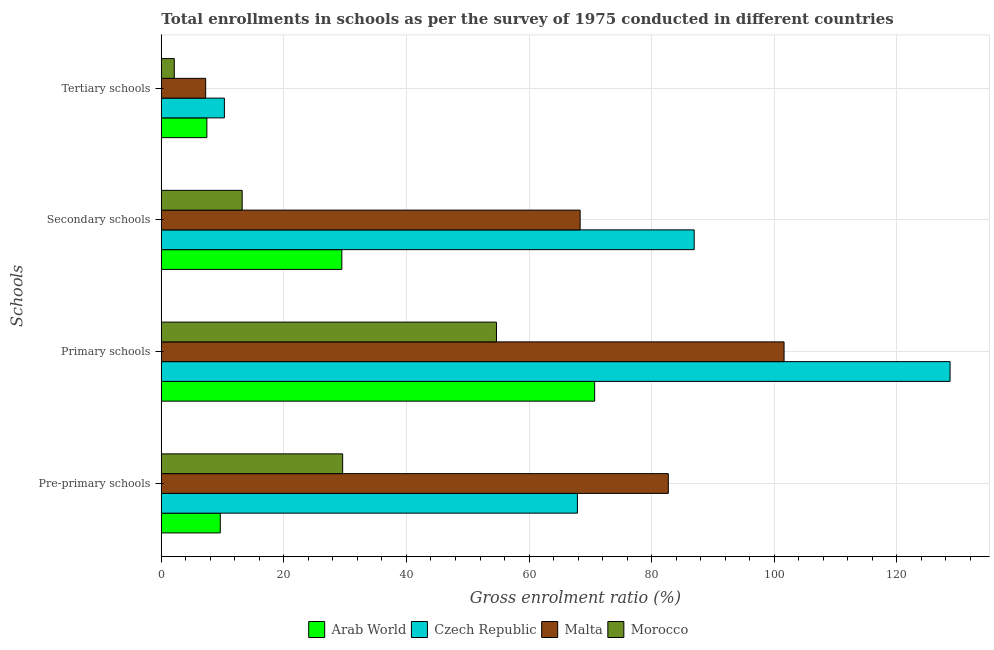How many groups of bars are there?
Offer a very short reply. 4. Are the number of bars per tick equal to the number of legend labels?
Your answer should be compact. Yes. How many bars are there on the 3rd tick from the top?
Offer a very short reply. 4. What is the label of the 2nd group of bars from the top?
Your answer should be compact. Secondary schools. What is the gross enrolment ratio in pre-primary schools in Malta?
Provide a short and direct response. 82.73. Across all countries, what is the maximum gross enrolment ratio in pre-primary schools?
Offer a terse response. 82.73. Across all countries, what is the minimum gross enrolment ratio in tertiary schools?
Provide a succinct answer. 2.12. In which country was the gross enrolment ratio in secondary schools maximum?
Your response must be concise. Czech Republic. In which country was the gross enrolment ratio in secondary schools minimum?
Provide a short and direct response. Morocco. What is the total gross enrolment ratio in secondary schools in the graph?
Offer a very short reply. 197.94. What is the difference between the gross enrolment ratio in secondary schools in Malta and that in Czech Republic?
Your answer should be very brief. -18.61. What is the difference between the gross enrolment ratio in pre-primary schools in Morocco and the gross enrolment ratio in tertiary schools in Czech Republic?
Offer a terse response. 19.3. What is the average gross enrolment ratio in pre-primary schools per country?
Offer a terse response. 47.46. What is the difference between the gross enrolment ratio in secondary schools and gross enrolment ratio in tertiary schools in Malta?
Keep it short and to the point. 61.11. What is the ratio of the gross enrolment ratio in pre-primary schools in Morocco to that in Czech Republic?
Make the answer very short. 0.44. Is the difference between the gross enrolment ratio in secondary schools in Czech Republic and Malta greater than the difference between the gross enrolment ratio in tertiary schools in Czech Republic and Malta?
Your response must be concise. Yes. What is the difference between the highest and the second highest gross enrolment ratio in tertiary schools?
Your answer should be compact. 2.86. What is the difference between the highest and the lowest gross enrolment ratio in pre-primary schools?
Give a very brief answer. 73.1. In how many countries, is the gross enrolment ratio in primary schools greater than the average gross enrolment ratio in primary schools taken over all countries?
Provide a short and direct response. 2. Is it the case that in every country, the sum of the gross enrolment ratio in secondary schools and gross enrolment ratio in pre-primary schools is greater than the sum of gross enrolment ratio in primary schools and gross enrolment ratio in tertiary schools?
Your response must be concise. Yes. What does the 2nd bar from the top in Secondary schools represents?
Offer a terse response. Malta. What does the 4th bar from the bottom in Primary schools represents?
Offer a terse response. Morocco. Is it the case that in every country, the sum of the gross enrolment ratio in pre-primary schools and gross enrolment ratio in primary schools is greater than the gross enrolment ratio in secondary schools?
Keep it short and to the point. Yes. How many bars are there?
Your answer should be compact. 16. Are all the bars in the graph horizontal?
Provide a short and direct response. Yes. How many countries are there in the graph?
Provide a short and direct response. 4. What is the difference between two consecutive major ticks on the X-axis?
Provide a succinct answer. 20. Are the values on the major ticks of X-axis written in scientific E-notation?
Give a very brief answer. No. How many legend labels are there?
Make the answer very short. 4. What is the title of the graph?
Ensure brevity in your answer.  Total enrollments in schools as per the survey of 1975 conducted in different countries. Does "Portugal" appear as one of the legend labels in the graph?
Offer a very short reply. No. What is the label or title of the X-axis?
Ensure brevity in your answer.  Gross enrolment ratio (%). What is the label or title of the Y-axis?
Give a very brief answer. Schools. What is the Gross enrolment ratio (%) in Arab World in Pre-primary schools?
Provide a short and direct response. 9.62. What is the Gross enrolment ratio (%) in Czech Republic in Pre-primary schools?
Your answer should be compact. 67.9. What is the Gross enrolment ratio (%) in Malta in Pre-primary schools?
Your answer should be compact. 82.73. What is the Gross enrolment ratio (%) of Morocco in Pre-primary schools?
Your response must be concise. 29.59. What is the Gross enrolment ratio (%) in Arab World in Primary schools?
Ensure brevity in your answer.  70.71. What is the Gross enrolment ratio (%) in Czech Republic in Primary schools?
Give a very brief answer. 128.7. What is the Gross enrolment ratio (%) in Malta in Primary schools?
Your answer should be compact. 101.62. What is the Gross enrolment ratio (%) in Morocco in Primary schools?
Your answer should be very brief. 54.69. What is the Gross enrolment ratio (%) in Arab World in Secondary schools?
Offer a very short reply. 29.46. What is the Gross enrolment ratio (%) in Czech Republic in Secondary schools?
Keep it short and to the point. 86.95. What is the Gross enrolment ratio (%) of Malta in Secondary schools?
Keep it short and to the point. 68.34. What is the Gross enrolment ratio (%) of Morocco in Secondary schools?
Your answer should be very brief. 13.19. What is the Gross enrolment ratio (%) in Arab World in Tertiary schools?
Make the answer very short. 7.44. What is the Gross enrolment ratio (%) in Czech Republic in Tertiary schools?
Give a very brief answer. 10.29. What is the Gross enrolment ratio (%) in Malta in Tertiary schools?
Provide a succinct answer. 7.24. What is the Gross enrolment ratio (%) in Morocco in Tertiary schools?
Make the answer very short. 2.12. Across all Schools, what is the maximum Gross enrolment ratio (%) of Arab World?
Keep it short and to the point. 70.71. Across all Schools, what is the maximum Gross enrolment ratio (%) in Czech Republic?
Your answer should be very brief. 128.7. Across all Schools, what is the maximum Gross enrolment ratio (%) in Malta?
Make the answer very short. 101.62. Across all Schools, what is the maximum Gross enrolment ratio (%) in Morocco?
Keep it short and to the point. 54.69. Across all Schools, what is the minimum Gross enrolment ratio (%) in Arab World?
Give a very brief answer. 7.44. Across all Schools, what is the minimum Gross enrolment ratio (%) in Czech Republic?
Provide a short and direct response. 10.29. Across all Schools, what is the minimum Gross enrolment ratio (%) in Malta?
Make the answer very short. 7.24. Across all Schools, what is the minimum Gross enrolment ratio (%) in Morocco?
Make the answer very short. 2.12. What is the total Gross enrolment ratio (%) of Arab World in the graph?
Ensure brevity in your answer.  117.22. What is the total Gross enrolment ratio (%) in Czech Republic in the graph?
Give a very brief answer. 293.84. What is the total Gross enrolment ratio (%) in Malta in the graph?
Your response must be concise. 259.92. What is the total Gross enrolment ratio (%) of Morocco in the graph?
Provide a succinct answer. 99.58. What is the difference between the Gross enrolment ratio (%) of Arab World in Pre-primary schools and that in Primary schools?
Keep it short and to the point. -61.09. What is the difference between the Gross enrolment ratio (%) in Czech Republic in Pre-primary schools and that in Primary schools?
Ensure brevity in your answer.  -60.8. What is the difference between the Gross enrolment ratio (%) in Malta in Pre-primary schools and that in Primary schools?
Your answer should be compact. -18.89. What is the difference between the Gross enrolment ratio (%) of Morocco in Pre-primary schools and that in Primary schools?
Offer a terse response. -25.1. What is the difference between the Gross enrolment ratio (%) of Arab World in Pre-primary schools and that in Secondary schools?
Provide a succinct answer. -19.83. What is the difference between the Gross enrolment ratio (%) in Czech Republic in Pre-primary schools and that in Secondary schools?
Offer a terse response. -19.05. What is the difference between the Gross enrolment ratio (%) of Malta in Pre-primary schools and that in Secondary schools?
Provide a short and direct response. 14.38. What is the difference between the Gross enrolment ratio (%) of Morocco in Pre-primary schools and that in Secondary schools?
Provide a succinct answer. 16.39. What is the difference between the Gross enrolment ratio (%) of Arab World in Pre-primary schools and that in Tertiary schools?
Your answer should be very brief. 2.19. What is the difference between the Gross enrolment ratio (%) of Czech Republic in Pre-primary schools and that in Tertiary schools?
Your answer should be very brief. 57.61. What is the difference between the Gross enrolment ratio (%) of Malta in Pre-primary schools and that in Tertiary schools?
Your answer should be compact. 75.49. What is the difference between the Gross enrolment ratio (%) of Morocco in Pre-primary schools and that in Tertiary schools?
Offer a very short reply. 27.47. What is the difference between the Gross enrolment ratio (%) in Arab World in Primary schools and that in Secondary schools?
Your response must be concise. 41.25. What is the difference between the Gross enrolment ratio (%) of Czech Republic in Primary schools and that in Secondary schools?
Provide a succinct answer. 41.75. What is the difference between the Gross enrolment ratio (%) in Malta in Primary schools and that in Secondary schools?
Offer a very short reply. 33.27. What is the difference between the Gross enrolment ratio (%) of Morocco in Primary schools and that in Secondary schools?
Give a very brief answer. 41.49. What is the difference between the Gross enrolment ratio (%) of Arab World in Primary schools and that in Tertiary schools?
Your answer should be compact. 63.27. What is the difference between the Gross enrolment ratio (%) in Czech Republic in Primary schools and that in Tertiary schools?
Your response must be concise. 118.41. What is the difference between the Gross enrolment ratio (%) of Malta in Primary schools and that in Tertiary schools?
Your response must be concise. 94.38. What is the difference between the Gross enrolment ratio (%) in Morocco in Primary schools and that in Tertiary schools?
Provide a short and direct response. 52.57. What is the difference between the Gross enrolment ratio (%) of Arab World in Secondary schools and that in Tertiary schools?
Your answer should be very brief. 22.02. What is the difference between the Gross enrolment ratio (%) in Czech Republic in Secondary schools and that in Tertiary schools?
Your answer should be very brief. 76.66. What is the difference between the Gross enrolment ratio (%) of Malta in Secondary schools and that in Tertiary schools?
Provide a succinct answer. 61.11. What is the difference between the Gross enrolment ratio (%) in Morocco in Secondary schools and that in Tertiary schools?
Your answer should be very brief. 11.08. What is the difference between the Gross enrolment ratio (%) of Arab World in Pre-primary schools and the Gross enrolment ratio (%) of Czech Republic in Primary schools?
Make the answer very short. -119.08. What is the difference between the Gross enrolment ratio (%) of Arab World in Pre-primary schools and the Gross enrolment ratio (%) of Malta in Primary schools?
Give a very brief answer. -91.99. What is the difference between the Gross enrolment ratio (%) in Arab World in Pre-primary schools and the Gross enrolment ratio (%) in Morocco in Primary schools?
Ensure brevity in your answer.  -45.07. What is the difference between the Gross enrolment ratio (%) of Czech Republic in Pre-primary schools and the Gross enrolment ratio (%) of Malta in Primary schools?
Keep it short and to the point. -33.72. What is the difference between the Gross enrolment ratio (%) of Czech Republic in Pre-primary schools and the Gross enrolment ratio (%) of Morocco in Primary schools?
Provide a succinct answer. 13.21. What is the difference between the Gross enrolment ratio (%) of Malta in Pre-primary schools and the Gross enrolment ratio (%) of Morocco in Primary schools?
Keep it short and to the point. 28.04. What is the difference between the Gross enrolment ratio (%) in Arab World in Pre-primary schools and the Gross enrolment ratio (%) in Czech Republic in Secondary schools?
Make the answer very short. -77.33. What is the difference between the Gross enrolment ratio (%) in Arab World in Pre-primary schools and the Gross enrolment ratio (%) in Malta in Secondary schools?
Give a very brief answer. -58.72. What is the difference between the Gross enrolment ratio (%) in Arab World in Pre-primary schools and the Gross enrolment ratio (%) in Morocco in Secondary schools?
Give a very brief answer. -3.57. What is the difference between the Gross enrolment ratio (%) of Czech Republic in Pre-primary schools and the Gross enrolment ratio (%) of Malta in Secondary schools?
Your answer should be very brief. -0.45. What is the difference between the Gross enrolment ratio (%) of Czech Republic in Pre-primary schools and the Gross enrolment ratio (%) of Morocco in Secondary schools?
Your response must be concise. 54.7. What is the difference between the Gross enrolment ratio (%) of Malta in Pre-primary schools and the Gross enrolment ratio (%) of Morocco in Secondary schools?
Provide a short and direct response. 69.53. What is the difference between the Gross enrolment ratio (%) of Arab World in Pre-primary schools and the Gross enrolment ratio (%) of Czech Republic in Tertiary schools?
Your answer should be compact. -0.67. What is the difference between the Gross enrolment ratio (%) of Arab World in Pre-primary schools and the Gross enrolment ratio (%) of Malta in Tertiary schools?
Your answer should be compact. 2.39. What is the difference between the Gross enrolment ratio (%) in Arab World in Pre-primary schools and the Gross enrolment ratio (%) in Morocco in Tertiary schools?
Provide a short and direct response. 7.51. What is the difference between the Gross enrolment ratio (%) in Czech Republic in Pre-primary schools and the Gross enrolment ratio (%) in Malta in Tertiary schools?
Make the answer very short. 60.66. What is the difference between the Gross enrolment ratio (%) in Czech Republic in Pre-primary schools and the Gross enrolment ratio (%) in Morocco in Tertiary schools?
Your response must be concise. 65.78. What is the difference between the Gross enrolment ratio (%) of Malta in Pre-primary schools and the Gross enrolment ratio (%) of Morocco in Tertiary schools?
Provide a succinct answer. 80.61. What is the difference between the Gross enrolment ratio (%) in Arab World in Primary schools and the Gross enrolment ratio (%) in Czech Republic in Secondary schools?
Offer a very short reply. -16.24. What is the difference between the Gross enrolment ratio (%) of Arab World in Primary schools and the Gross enrolment ratio (%) of Malta in Secondary schools?
Ensure brevity in your answer.  2.37. What is the difference between the Gross enrolment ratio (%) of Arab World in Primary schools and the Gross enrolment ratio (%) of Morocco in Secondary schools?
Ensure brevity in your answer.  57.51. What is the difference between the Gross enrolment ratio (%) of Czech Republic in Primary schools and the Gross enrolment ratio (%) of Malta in Secondary schools?
Provide a succinct answer. 60.36. What is the difference between the Gross enrolment ratio (%) in Czech Republic in Primary schools and the Gross enrolment ratio (%) in Morocco in Secondary schools?
Your response must be concise. 115.51. What is the difference between the Gross enrolment ratio (%) of Malta in Primary schools and the Gross enrolment ratio (%) of Morocco in Secondary schools?
Ensure brevity in your answer.  88.42. What is the difference between the Gross enrolment ratio (%) of Arab World in Primary schools and the Gross enrolment ratio (%) of Czech Republic in Tertiary schools?
Make the answer very short. 60.42. What is the difference between the Gross enrolment ratio (%) in Arab World in Primary schools and the Gross enrolment ratio (%) in Malta in Tertiary schools?
Keep it short and to the point. 63.47. What is the difference between the Gross enrolment ratio (%) in Arab World in Primary schools and the Gross enrolment ratio (%) in Morocco in Tertiary schools?
Make the answer very short. 68.59. What is the difference between the Gross enrolment ratio (%) of Czech Republic in Primary schools and the Gross enrolment ratio (%) of Malta in Tertiary schools?
Provide a short and direct response. 121.46. What is the difference between the Gross enrolment ratio (%) of Czech Republic in Primary schools and the Gross enrolment ratio (%) of Morocco in Tertiary schools?
Ensure brevity in your answer.  126.59. What is the difference between the Gross enrolment ratio (%) of Malta in Primary schools and the Gross enrolment ratio (%) of Morocco in Tertiary schools?
Your answer should be compact. 99.5. What is the difference between the Gross enrolment ratio (%) of Arab World in Secondary schools and the Gross enrolment ratio (%) of Czech Republic in Tertiary schools?
Provide a short and direct response. 19.17. What is the difference between the Gross enrolment ratio (%) in Arab World in Secondary schools and the Gross enrolment ratio (%) in Malta in Tertiary schools?
Keep it short and to the point. 22.22. What is the difference between the Gross enrolment ratio (%) of Arab World in Secondary schools and the Gross enrolment ratio (%) of Morocco in Tertiary schools?
Your answer should be very brief. 27.34. What is the difference between the Gross enrolment ratio (%) in Czech Republic in Secondary schools and the Gross enrolment ratio (%) in Malta in Tertiary schools?
Give a very brief answer. 79.71. What is the difference between the Gross enrolment ratio (%) of Czech Republic in Secondary schools and the Gross enrolment ratio (%) of Morocco in Tertiary schools?
Offer a very short reply. 84.84. What is the difference between the Gross enrolment ratio (%) of Malta in Secondary schools and the Gross enrolment ratio (%) of Morocco in Tertiary schools?
Give a very brief answer. 66.23. What is the average Gross enrolment ratio (%) in Arab World per Schools?
Your answer should be very brief. 29.31. What is the average Gross enrolment ratio (%) of Czech Republic per Schools?
Your response must be concise. 73.46. What is the average Gross enrolment ratio (%) in Malta per Schools?
Your answer should be compact. 64.98. What is the average Gross enrolment ratio (%) of Morocco per Schools?
Your answer should be compact. 24.9. What is the difference between the Gross enrolment ratio (%) of Arab World and Gross enrolment ratio (%) of Czech Republic in Pre-primary schools?
Your answer should be very brief. -58.27. What is the difference between the Gross enrolment ratio (%) in Arab World and Gross enrolment ratio (%) in Malta in Pre-primary schools?
Your answer should be very brief. -73.1. What is the difference between the Gross enrolment ratio (%) of Arab World and Gross enrolment ratio (%) of Morocco in Pre-primary schools?
Ensure brevity in your answer.  -19.96. What is the difference between the Gross enrolment ratio (%) of Czech Republic and Gross enrolment ratio (%) of Malta in Pre-primary schools?
Keep it short and to the point. -14.83. What is the difference between the Gross enrolment ratio (%) of Czech Republic and Gross enrolment ratio (%) of Morocco in Pre-primary schools?
Make the answer very short. 38.31. What is the difference between the Gross enrolment ratio (%) in Malta and Gross enrolment ratio (%) in Morocco in Pre-primary schools?
Your answer should be very brief. 53.14. What is the difference between the Gross enrolment ratio (%) of Arab World and Gross enrolment ratio (%) of Czech Republic in Primary schools?
Give a very brief answer. -57.99. What is the difference between the Gross enrolment ratio (%) in Arab World and Gross enrolment ratio (%) in Malta in Primary schools?
Offer a very short reply. -30.91. What is the difference between the Gross enrolment ratio (%) of Arab World and Gross enrolment ratio (%) of Morocco in Primary schools?
Offer a very short reply. 16.02. What is the difference between the Gross enrolment ratio (%) in Czech Republic and Gross enrolment ratio (%) in Malta in Primary schools?
Provide a short and direct response. 27.09. What is the difference between the Gross enrolment ratio (%) in Czech Republic and Gross enrolment ratio (%) in Morocco in Primary schools?
Offer a terse response. 74.01. What is the difference between the Gross enrolment ratio (%) in Malta and Gross enrolment ratio (%) in Morocco in Primary schools?
Ensure brevity in your answer.  46.93. What is the difference between the Gross enrolment ratio (%) in Arab World and Gross enrolment ratio (%) in Czech Republic in Secondary schools?
Your answer should be very brief. -57.49. What is the difference between the Gross enrolment ratio (%) of Arab World and Gross enrolment ratio (%) of Malta in Secondary schools?
Offer a very short reply. -38.89. What is the difference between the Gross enrolment ratio (%) in Arab World and Gross enrolment ratio (%) in Morocco in Secondary schools?
Your response must be concise. 16.26. What is the difference between the Gross enrolment ratio (%) in Czech Republic and Gross enrolment ratio (%) in Malta in Secondary schools?
Ensure brevity in your answer.  18.61. What is the difference between the Gross enrolment ratio (%) of Czech Republic and Gross enrolment ratio (%) of Morocco in Secondary schools?
Make the answer very short. 73.76. What is the difference between the Gross enrolment ratio (%) in Malta and Gross enrolment ratio (%) in Morocco in Secondary schools?
Provide a short and direct response. 55.15. What is the difference between the Gross enrolment ratio (%) in Arab World and Gross enrolment ratio (%) in Czech Republic in Tertiary schools?
Your answer should be very brief. -2.86. What is the difference between the Gross enrolment ratio (%) in Arab World and Gross enrolment ratio (%) in Malta in Tertiary schools?
Provide a succinct answer. 0.2. What is the difference between the Gross enrolment ratio (%) in Arab World and Gross enrolment ratio (%) in Morocco in Tertiary schools?
Offer a terse response. 5.32. What is the difference between the Gross enrolment ratio (%) of Czech Republic and Gross enrolment ratio (%) of Malta in Tertiary schools?
Make the answer very short. 3.05. What is the difference between the Gross enrolment ratio (%) of Czech Republic and Gross enrolment ratio (%) of Morocco in Tertiary schools?
Provide a short and direct response. 8.18. What is the difference between the Gross enrolment ratio (%) in Malta and Gross enrolment ratio (%) in Morocco in Tertiary schools?
Your response must be concise. 5.12. What is the ratio of the Gross enrolment ratio (%) of Arab World in Pre-primary schools to that in Primary schools?
Make the answer very short. 0.14. What is the ratio of the Gross enrolment ratio (%) of Czech Republic in Pre-primary schools to that in Primary schools?
Make the answer very short. 0.53. What is the ratio of the Gross enrolment ratio (%) in Malta in Pre-primary schools to that in Primary schools?
Make the answer very short. 0.81. What is the ratio of the Gross enrolment ratio (%) in Morocco in Pre-primary schools to that in Primary schools?
Offer a terse response. 0.54. What is the ratio of the Gross enrolment ratio (%) in Arab World in Pre-primary schools to that in Secondary schools?
Make the answer very short. 0.33. What is the ratio of the Gross enrolment ratio (%) in Czech Republic in Pre-primary schools to that in Secondary schools?
Give a very brief answer. 0.78. What is the ratio of the Gross enrolment ratio (%) in Malta in Pre-primary schools to that in Secondary schools?
Provide a succinct answer. 1.21. What is the ratio of the Gross enrolment ratio (%) in Morocco in Pre-primary schools to that in Secondary schools?
Your answer should be compact. 2.24. What is the ratio of the Gross enrolment ratio (%) of Arab World in Pre-primary schools to that in Tertiary schools?
Keep it short and to the point. 1.29. What is the ratio of the Gross enrolment ratio (%) of Czech Republic in Pre-primary schools to that in Tertiary schools?
Your answer should be very brief. 6.6. What is the ratio of the Gross enrolment ratio (%) of Malta in Pre-primary schools to that in Tertiary schools?
Your answer should be compact. 11.43. What is the ratio of the Gross enrolment ratio (%) in Morocco in Pre-primary schools to that in Tertiary schools?
Give a very brief answer. 13.99. What is the ratio of the Gross enrolment ratio (%) in Arab World in Primary schools to that in Secondary schools?
Give a very brief answer. 2.4. What is the ratio of the Gross enrolment ratio (%) of Czech Republic in Primary schools to that in Secondary schools?
Make the answer very short. 1.48. What is the ratio of the Gross enrolment ratio (%) in Malta in Primary schools to that in Secondary schools?
Provide a succinct answer. 1.49. What is the ratio of the Gross enrolment ratio (%) in Morocco in Primary schools to that in Secondary schools?
Offer a very short reply. 4.14. What is the ratio of the Gross enrolment ratio (%) in Arab World in Primary schools to that in Tertiary schools?
Your answer should be very brief. 9.51. What is the ratio of the Gross enrolment ratio (%) in Czech Republic in Primary schools to that in Tertiary schools?
Offer a terse response. 12.51. What is the ratio of the Gross enrolment ratio (%) in Malta in Primary schools to that in Tertiary schools?
Offer a very short reply. 14.04. What is the ratio of the Gross enrolment ratio (%) of Morocco in Primary schools to that in Tertiary schools?
Provide a short and direct response. 25.85. What is the ratio of the Gross enrolment ratio (%) in Arab World in Secondary schools to that in Tertiary schools?
Your answer should be compact. 3.96. What is the ratio of the Gross enrolment ratio (%) of Czech Republic in Secondary schools to that in Tertiary schools?
Offer a terse response. 8.45. What is the ratio of the Gross enrolment ratio (%) of Malta in Secondary schools to that in Tertiary schools?
Ensure brevity in your answer.  9.44. What is the ratio of the Gross enrolment ratio (%) in Morocco in Secondary schools to that in Tertiary schools?
Offer a very short reply. 6.24. What is the difference between the highest and the second highest Gross enrolment ratio (%) in Arab World?
Provide a succinct answer. 41.25. What is the difference between the highest and the second highest Gross enrolment ratio (%) in Czech Republic?
Provide a short and direct response. 41.75. What is the difference between the highest and the second highest Gross enrolment ratio (%) in Malta?
Provide a short and direct response. 18.89. What is the difference between the highest and the second highest Gross enrolment ratio (%) in Morocco?
Your answer should be very brief. 25.1. What is the difference between the highest and the lowest Gross enrolment ratio (%) in Arab World?
Your answer should be compact. 63.27. What is the difference between the highest and the lowest Gross enrolment ratio (%) in Czech Republic?
Keep it short and to the point. 118.41. What is the difference between the highest and the lowest Gross enrolment ratio (%) of Malta?
Your answer should be very brief. 94.38. What is the difference between the highest and the lowest Gross enrolment ratio (%) in Morocco?
Your answer should be very brief. 52.57. 